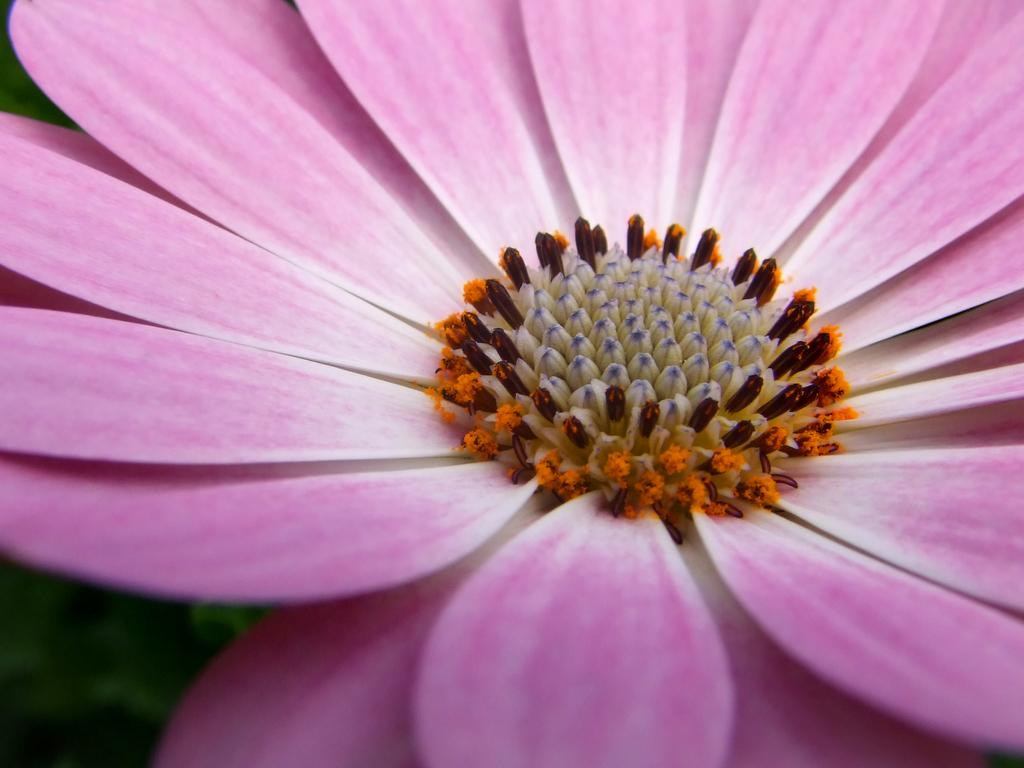What is the main subject of the image? There is a flower in the center of the image. Can you describe the appearance of the flower? The flower has multiple colors. What type of potato is being used to hold the flower in the image? There is no potato present in the image; the flower is not being held by any object. 